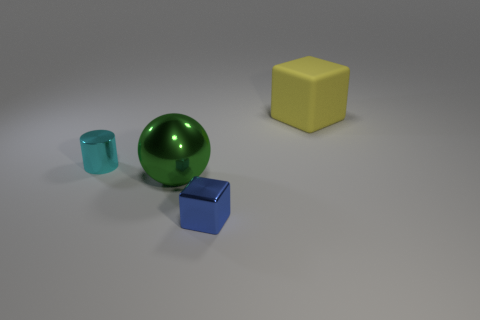Add 2 brown rubber things. How many objects exist? 6 Subtract all balls. How many objects are left? 3 Subtract all tiny cyan shiny cylinders. Subtract all small blue metallic objects. How many objects are left? 2 Add 2 big yellow cubes. How many big yellow cubes are left? 3 Add 4 large cubes. How many large cubes exist? 5 Subtract 0 purple cubes. How many objects are left? 4 